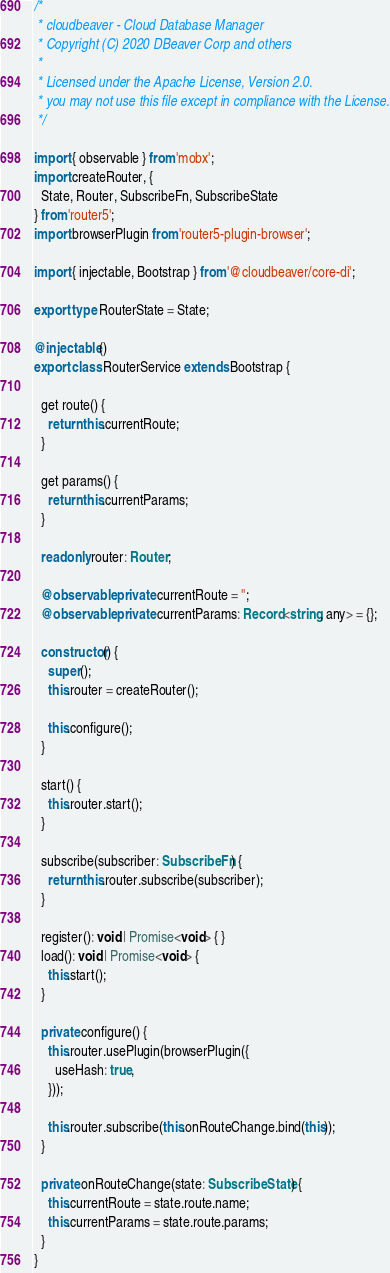Convert code to text. <code><loc_0><loc_0><loc_500><loc_500><_TypeScript_>/*
 * cloudbeaver - Cloud Database Manager
 * Copyright (C) 2020 DBeaver Corp and others
 *
 * Licensed under the Apache License, Version 2.0.
 * you may not use this file except in compliance with the License.
 */

import { observable } from 'mobx';
import createRouter, {
  State, Router, SubscribeFn, SubscribeState
} from 'router5';
import browserPlugin from 'router5-plugin-browser';

import { injectable, Bootstrap } from '@cloudbeaver/core-di';

export type RouterState = State;

@injectable()
export class RouterService extends Bootstrap {

  get route() {
    return this.currentRoute;
  }

  get params() {
    return this.currentParams;
  }

  readonly router: Router;

  @observable private currentRoute = '';
  @observable private currentParams: Record<string, any> = {};

  constructor() {
    super();
    this.router = createRouter();

    this.configure();
  }

  start() {
    this.router.start();
  }

  subscribe(subscriber: SubscribeFn) {
    return this.router.subscribe(subscriber);
  }

  register(): void | Promise<void> { }
  load(): void | Promise<void> {
    this.start();
  }

  private configure() {
    this.router.usePlugin(browserPlugin({
      useHash: true,
    }));

    this.router.subscribe(this.onRouteChange.bind(this));
  }

  private onRouteChange(state: SubscribeState) {
    this.currentRoute = state.route.name;
    this.currentParams = state.route.params;
  }
}
</code> 